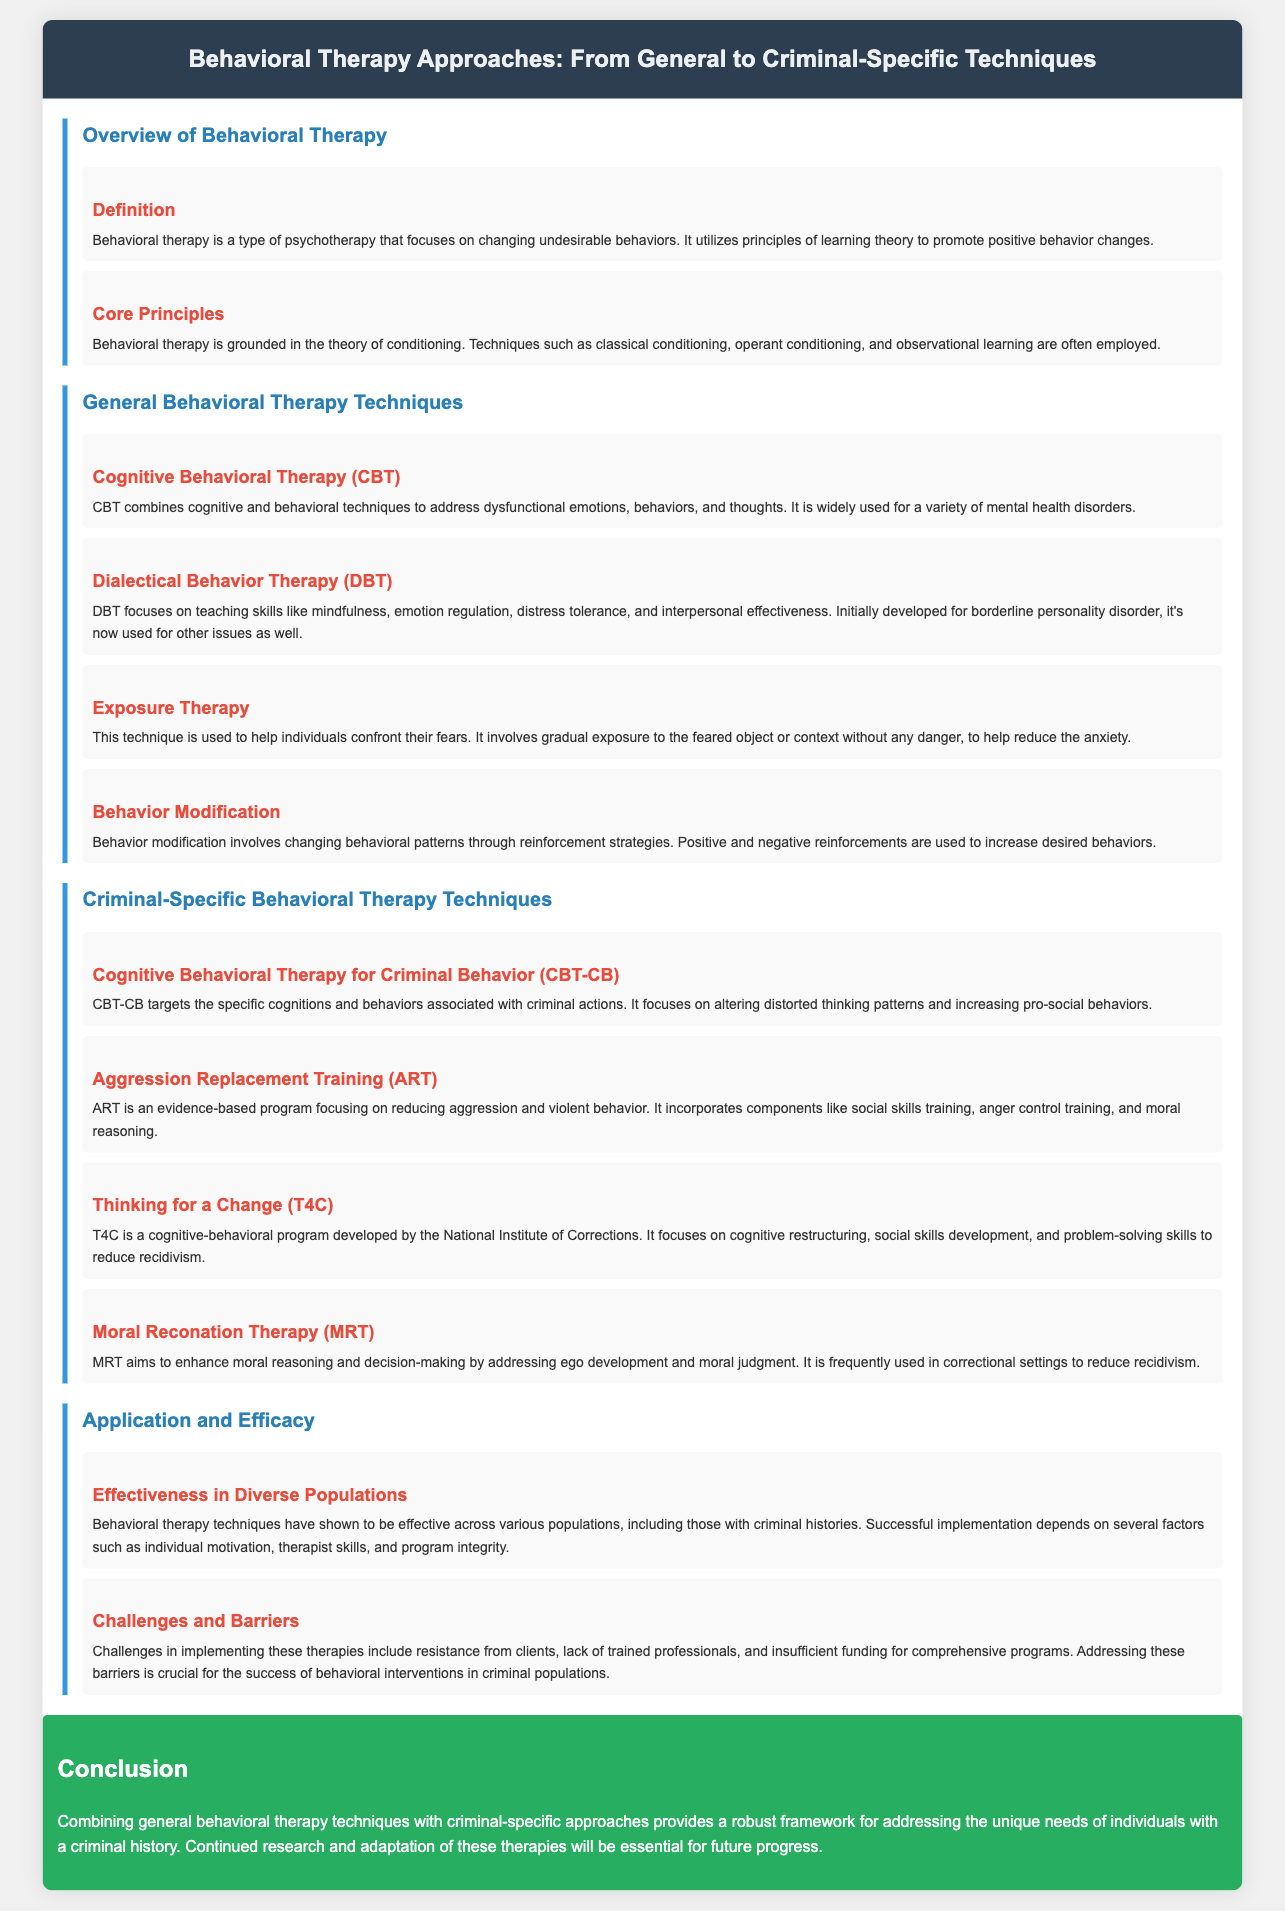What is the title of the document? The title is stated at the top of the document, highlighting the main topic covered.
Answer: Behavioral Therapy Approaches: From General to Criminal-Specific Techniques What therapy focuses on mindfulness and emotion regulation? The document specifies techniques along with their focus areas, leading to identifying this specific therapy.
Answer: Dialectical Behavior Therapy (DBT) What does ART stand for? The abbreviation is defined in the section discussing criminal-specific techniques, indicating its full form.
Answer: Aggression Replacement Training Which therapy is designed to target distorted thinking patterns in criminal behavior? The document discusses specific therapeutic approaches tailored for criminal behavior, leading to this identification.
Answer: Cognitive Behavioral Therapy for Criminal Behavior (CBT-CB) What are the core principles of behavioral therapy based on? The document provides foundational information about behavioral therapy establishment, leading to a concise definition.
Answer: Conditioning What is a key challenge mentioned for implementing these therapies? By analyzing the section on challenges, one finds specific barriers mentioned for the success of these programs.
Answer: Resistance How many general behavioral therapy techniques are listed? The number of techniques detailed under the general behavioral therapy section can be directly counted in the document.
Answer: Four What is the main goal of Moral Reconation Therapy? The document outlines the purpose of this therapy, indicating its focus on improving certain aspects of an individual's cognition.
Answer: Enhance moral reasoning What is the conclusion regarding combining therapy techniques? The document summarizes insights on the combination of therapeutic approaches in its conclusion, identifying the main takeaway.
Answer: Robust framework 